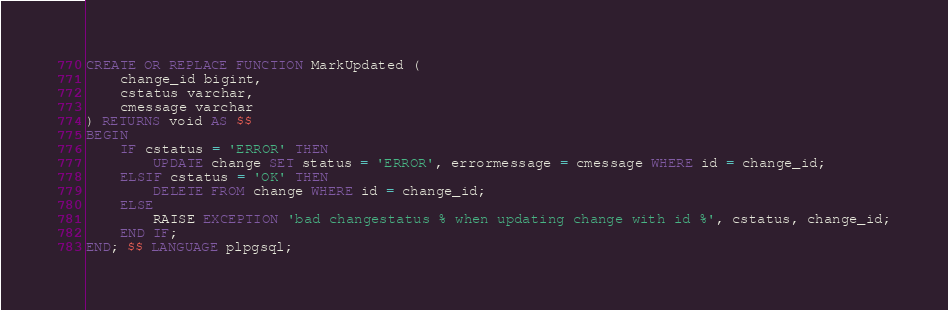<code> <loc_0><loc_0><loc_500><loc_500><_SQL_>CREATE OR REPLACE FUNCTION MarkUpdated (
	change_id bigint,
	cstatus varchar, 
	cmessage varchar 
) RETURNS void AS $$
BEGIN
	IF cstatus = 'ERROR' THEN
		UPDATE change SET status = 'ERROR', errormessage = cmessage WHERE id = change_id;
	ELSIF cstatus = 'OK' THEN
		DELETE FROM change WHERE id = change_id;
	ELSE
		RAISE EXCEPTION 'bad changestatus % when updating change with id %', cstatus, change_id;
	END IF;
END; $$ LANGUAGE plpgsql;
</code> 